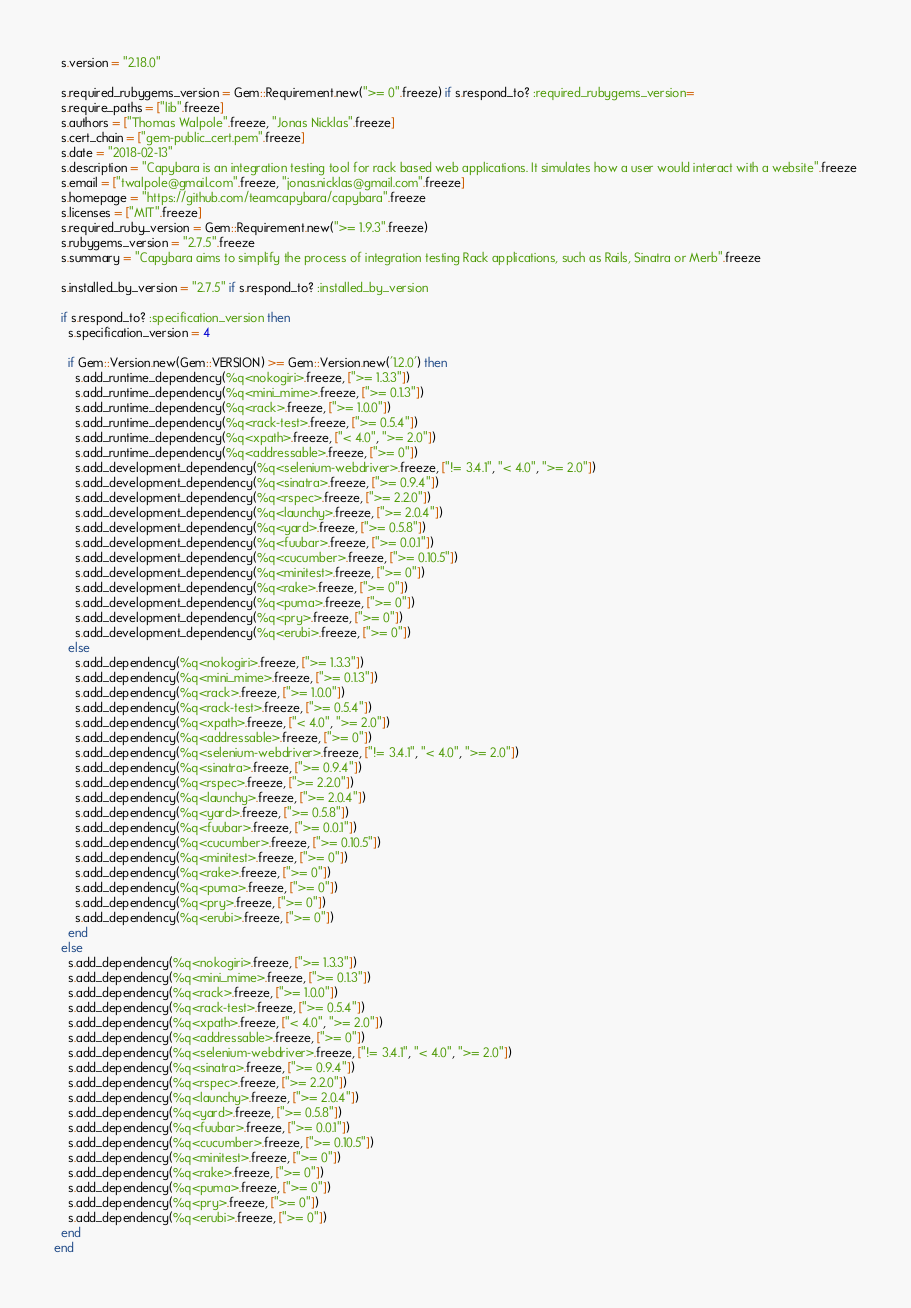Convert code to text. <code><loc_0><loc_0><loc_500><loc_500><_Ruby_>  s.version = "2.18.0"

  s.required_rubygems_version = Gem::Requirement.new(">= 0".freeze) if s.respond_to? :required_rubygems_version=
  s.require_paths = ["lib".freeze]
  s.authors = ["Thomas Walpole".freeze, "Jonas Nicklas".freeze]
  s.cert_chain = ["gem-public_cert.pem".freeze]
  s.date = "2018-02-13"
  s.description = "Capybara is an integration testing tool for rack based web applications. It simulates how a user would interact with a website".freeze
  s.email = ["twalpole@gmail.com".freeze, "jonas.nicklas@gmail.com".freeze]
  s.homepage = "https://github.com/teamcapybara/capybara".freeze
  s.licenses = ["MIT".freeze]
  s.required_ruby_version = Gem::Requirement.new(">= 1.9.3".freeze)
  s.rubygems_version = "2.7.5".freeze
  s.summary = "Capybara aims to simplify the process of integration testing Rack applications, such as Rails, Sinatra or Merb".freeze

  s.installed_by_version = "2.7.5" if s.respond_to? :installed_by_version

  if s.respond_to? :specification_version then
    s.specification_version = 4

    if Gem::Version.new(Gem::VERSION) >= Gem::Version.new('1.2.0') then
      s.add_runtime_dependency(%q<nokogiri>.freeze, [">= 1.3.3"])
      s.add_runtime_dependency(%q<mini_mime>.freeze, [">= 0.1.3"])
      s.add_runtime_dependency(%q<rack>.freeze, [">= 1.0.0"])
      s.add_runtime_dependency(%q<rack-test>.freeze, [">= 0.5.4"])
      s.add_runtime_dependency(%q<xpath>.freeze, ["< 4.0", ">= 2.0"])
      s.add_runtime_dependency(%q<addressable>.freeze, [">= 0"])
      s.add_development_dependency(%q<selenium-webdriver>.freeze, ["!= 3.4.1", "< 4.0", ">= 2.0"])
      s.add_development_dependency(%q<sinatra>.freeze, [">= 0.9.4"])
      s.add_development_dependency(%q<rspec>.freeze, [">= 2.2.0"])
      s.add_development_dependency(%q<launchy>.freeze, [">= 2.0.4"])
      s.add_development_dependency(%q<yard>.freeze, [">= 0.5.8"])
      s.add_development_dependency(%q<fuubar>.freeze, [">= 0.0.1"])
      s.add_development_dependency(%q<cucumber>.freeze, [">= 0.10.5"])
      s.add_development_dependency(%q<minitest>.freeze, [">= 0"])
      s.add_development_dependency(%q<rake>.freeze, [">= 0"])
      s.add_development_dependency(%q<puma>.freeze, [">= 0"])
      s.add_development_dependency(%q<pry>.freeze, [">= 0"])
      s.add_development_dependency(%q<erubi>.freeze, [">= 0"])
    else
      s.add_dependency(%q<nokogiri>.freeze, [">= 1.3.3"])
      s.add_dependency(%q<mini_mime>.freeze, [">= 0.1.3"])
      s.add_dependency(%q<rack>.freeze, [">= 1.0.0"])
      s.add_dependency(%q<rack-test>.freeze, [">= 0.5.4"])
      s.add_dependency(%q<xpath>.freeze, ["< 4.0", ">= 2.0"])
      s.add_dependency(%q<addressable>.freeze, [">= 0"])
      s.add_dependency(%q<selenium-webdriver>.freeze, ["!= 3.4.1", "< 4.0", ">= 2.0"])
      s.add_dependency(%q<sinatra>.freeze, [">= 0.9.4"])
      s.add_dependency(%q<rspec>.freeze, [">= 2.2.0"])
      s.add_dependency(%q<launchy>.freeze, [">= 2.0.4"])
      s.add_dependency(%q<yard>.freeze, [">= 0.5.8"])
      s.add_dependency(%q<fuubar>.freeze, [">= 0.0.1"])
      s.add_dependency(%q<cucumber>.freeze, [">= 0.10.5"])
      s.add_dependency(%q<minitest>.freeze, [">= 0"])
      s.add_dependency(%q<rake>.freeze, [">= 0"])
      s.add_dependency(%q<puma>.freeze, [">= 0"])
      s.add_dependency(%q<pry>.freeze, [">= 0"])
      s.add_dependency(%q<erubi>.freeze, [">= 0"])
    end
  else
    s.add_dependency(%q<nokogiri>.freeze, [">= 1.3.3"])
    s.add_dependency(%q<mini_mime>.freeze, [">= 0.1.3"])
    s.add_dependency(%q<rack>.freeze, [">= 1.0.0"])
    s.add_dependency(%q<rack-test>.freeze, [">= 0.5.4"])
    s.add_dependency(%q<xpath>.freeze, ["< 4.0", ">= 2.0"])
    s.add_dependency(%q<addressable>.freeze, [">= 0"])
    s.add_dependency(%q<selenium-webdriver>.freeze, ["!= 3.4.1", "< 4.0", ">= 2.0"])
    s.add_dependency(%q<sinatra>.freeze, [">= 0.9.4"])
    s.add_dependency(%q<rspec>.freeze, [">= 2.2.0"])
    s.add_dependency(%q<launchy>.freeze, [">= 2.0.4"])
    s.add_dependency(%q<yard>.freeze, [">= 0.5.8"])
    s.add_dependency(%q<fuubar>.freeze, [">= 0.0.1"])
    s.add_dependency(%q<cucumber>.freeze, [">= 0.10.5"])
    s.add_dependency(%q<minitest>.freeze, [">= 0"])
    s.add_dependency(%q<rake>.freeze, [">= 0"])
    s.add_dependency(%q<puma>.freeze, [">= 0"])
    s.add_dependency(%q<pry>.freeze, [">= 0"])
    s.add_dependency(%q<erubi>.freeze, [">= 0"])
  end
end
</code> 